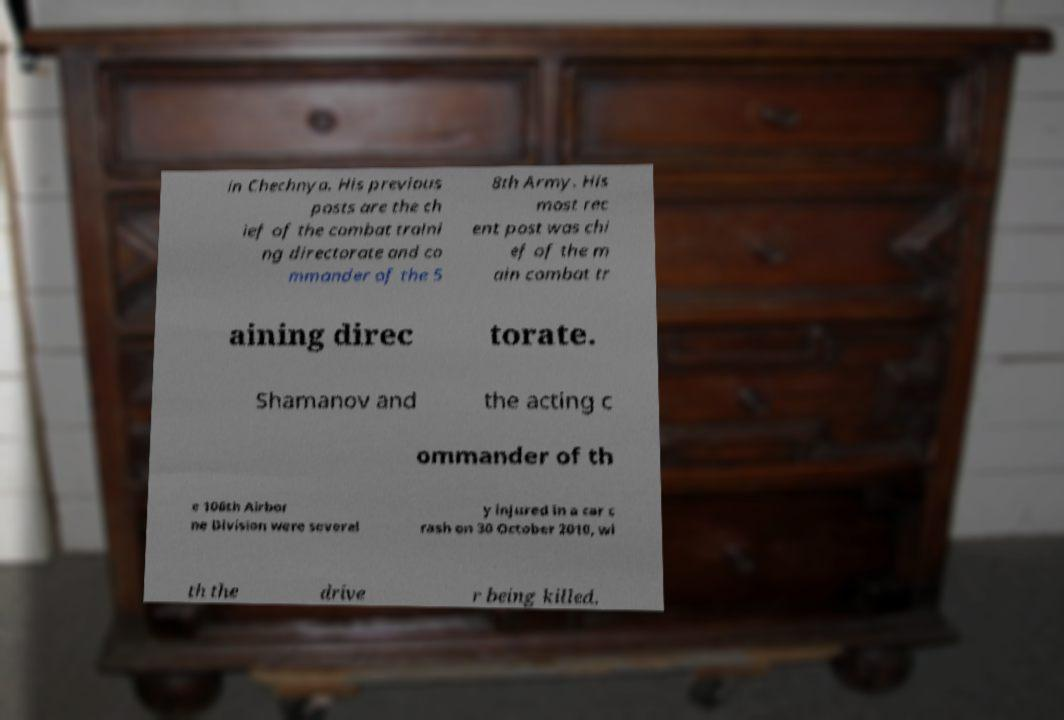For documentation purposes, I need the text within this image transcribed. Could you provide that? in Chechnya. His previous posts are the ch ief of the combat traini ng directorate and co mmander of the 5 8th Army. His most rec ent post was chi ef of the m ain combat tr aining direc torate. Shamanov and the acting c ommander of th e 106th Airbor ne Division were severel y injured in a car c rash on 30 October 2010, wi th the drive r being killed. 